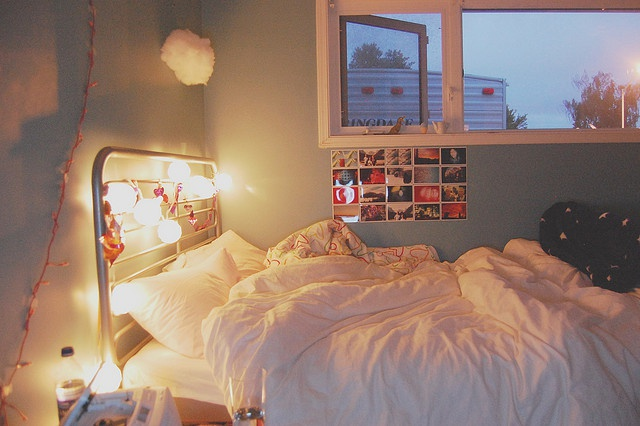Describe the objects in this image and their specific colors. I can see bed in black, gray, and tan tones, backpack in black and brown tones, cup in black, darkgray, tan, and gray tones, and bottle in black, tan, lightgray, and brown tones in this image. 